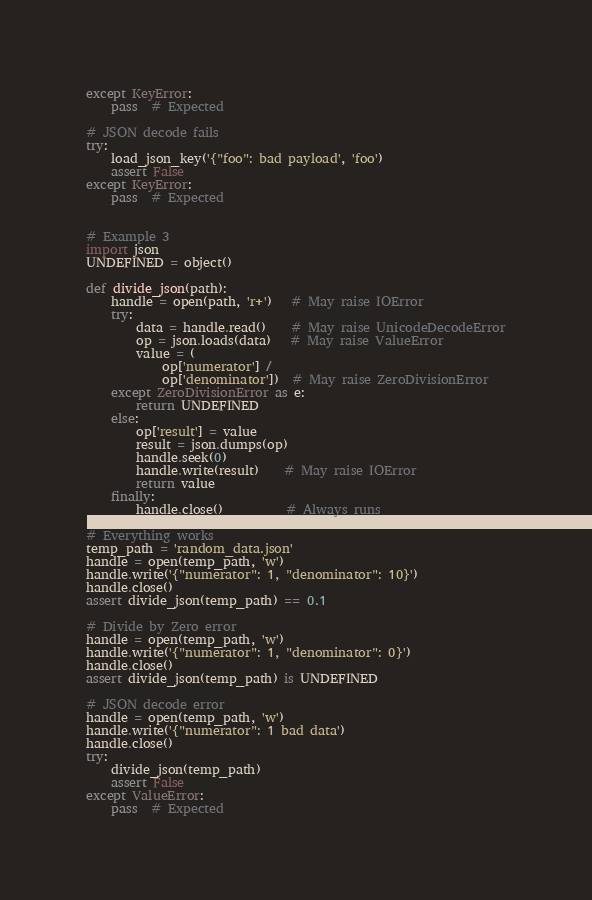Convert code to text. <code><loc_0><loc_0><loc_500><loc_500><_Python_>except KeyError:
    pass  # Expected

# JSON decode fails
try:
    load_json_key('{"foo": bad payload', 'foo')
    assert False
except KeyError:
    pass  # Expected


# Example 3
import json
UNDEFINED = object()

def divide_json(path):
    handle = open(path, 'r+')   # May raise IOError
    try:
        data = handle.read()    # May raise UnicodeDecodeError
        op = json.loads(data)   # May raise ValueError
        value = (
            op['numerator'] /
            op['denominator'])  # May raise ZeroDivisionError
    except ZeroDivisionError as e:
        return UNDEFINED
    else:
        op['result'] = value
        result = json.dumps(op)
        handle.seek(0)
        handle.write(result)    # May raise IOError
        return value
    finally:
        handle.close()          # Always runs

# Everything works
temp_path = 'random_data.json'
handle = open(temp_path, 'w')
handle.write('{"numerator": 1, "denominator": 10}')
handle.close()
assert divide_json(temp_path) == 0.1

# Divide by Zero error
handle = open(temp_path, 'w')
handle.write('{"numerator": 1, "denominator": 0}')
handle.close()
assert divide_json(temp_path) is UNDEFINED

# JSON decode error
handle = open(temp_path, 'w')
handle.write('{"numerator": 1 bad data')
handle.close()
try:
    divide_json(temp_path)
    assert False
except ValueError:
    pass  # Expected
</code> 